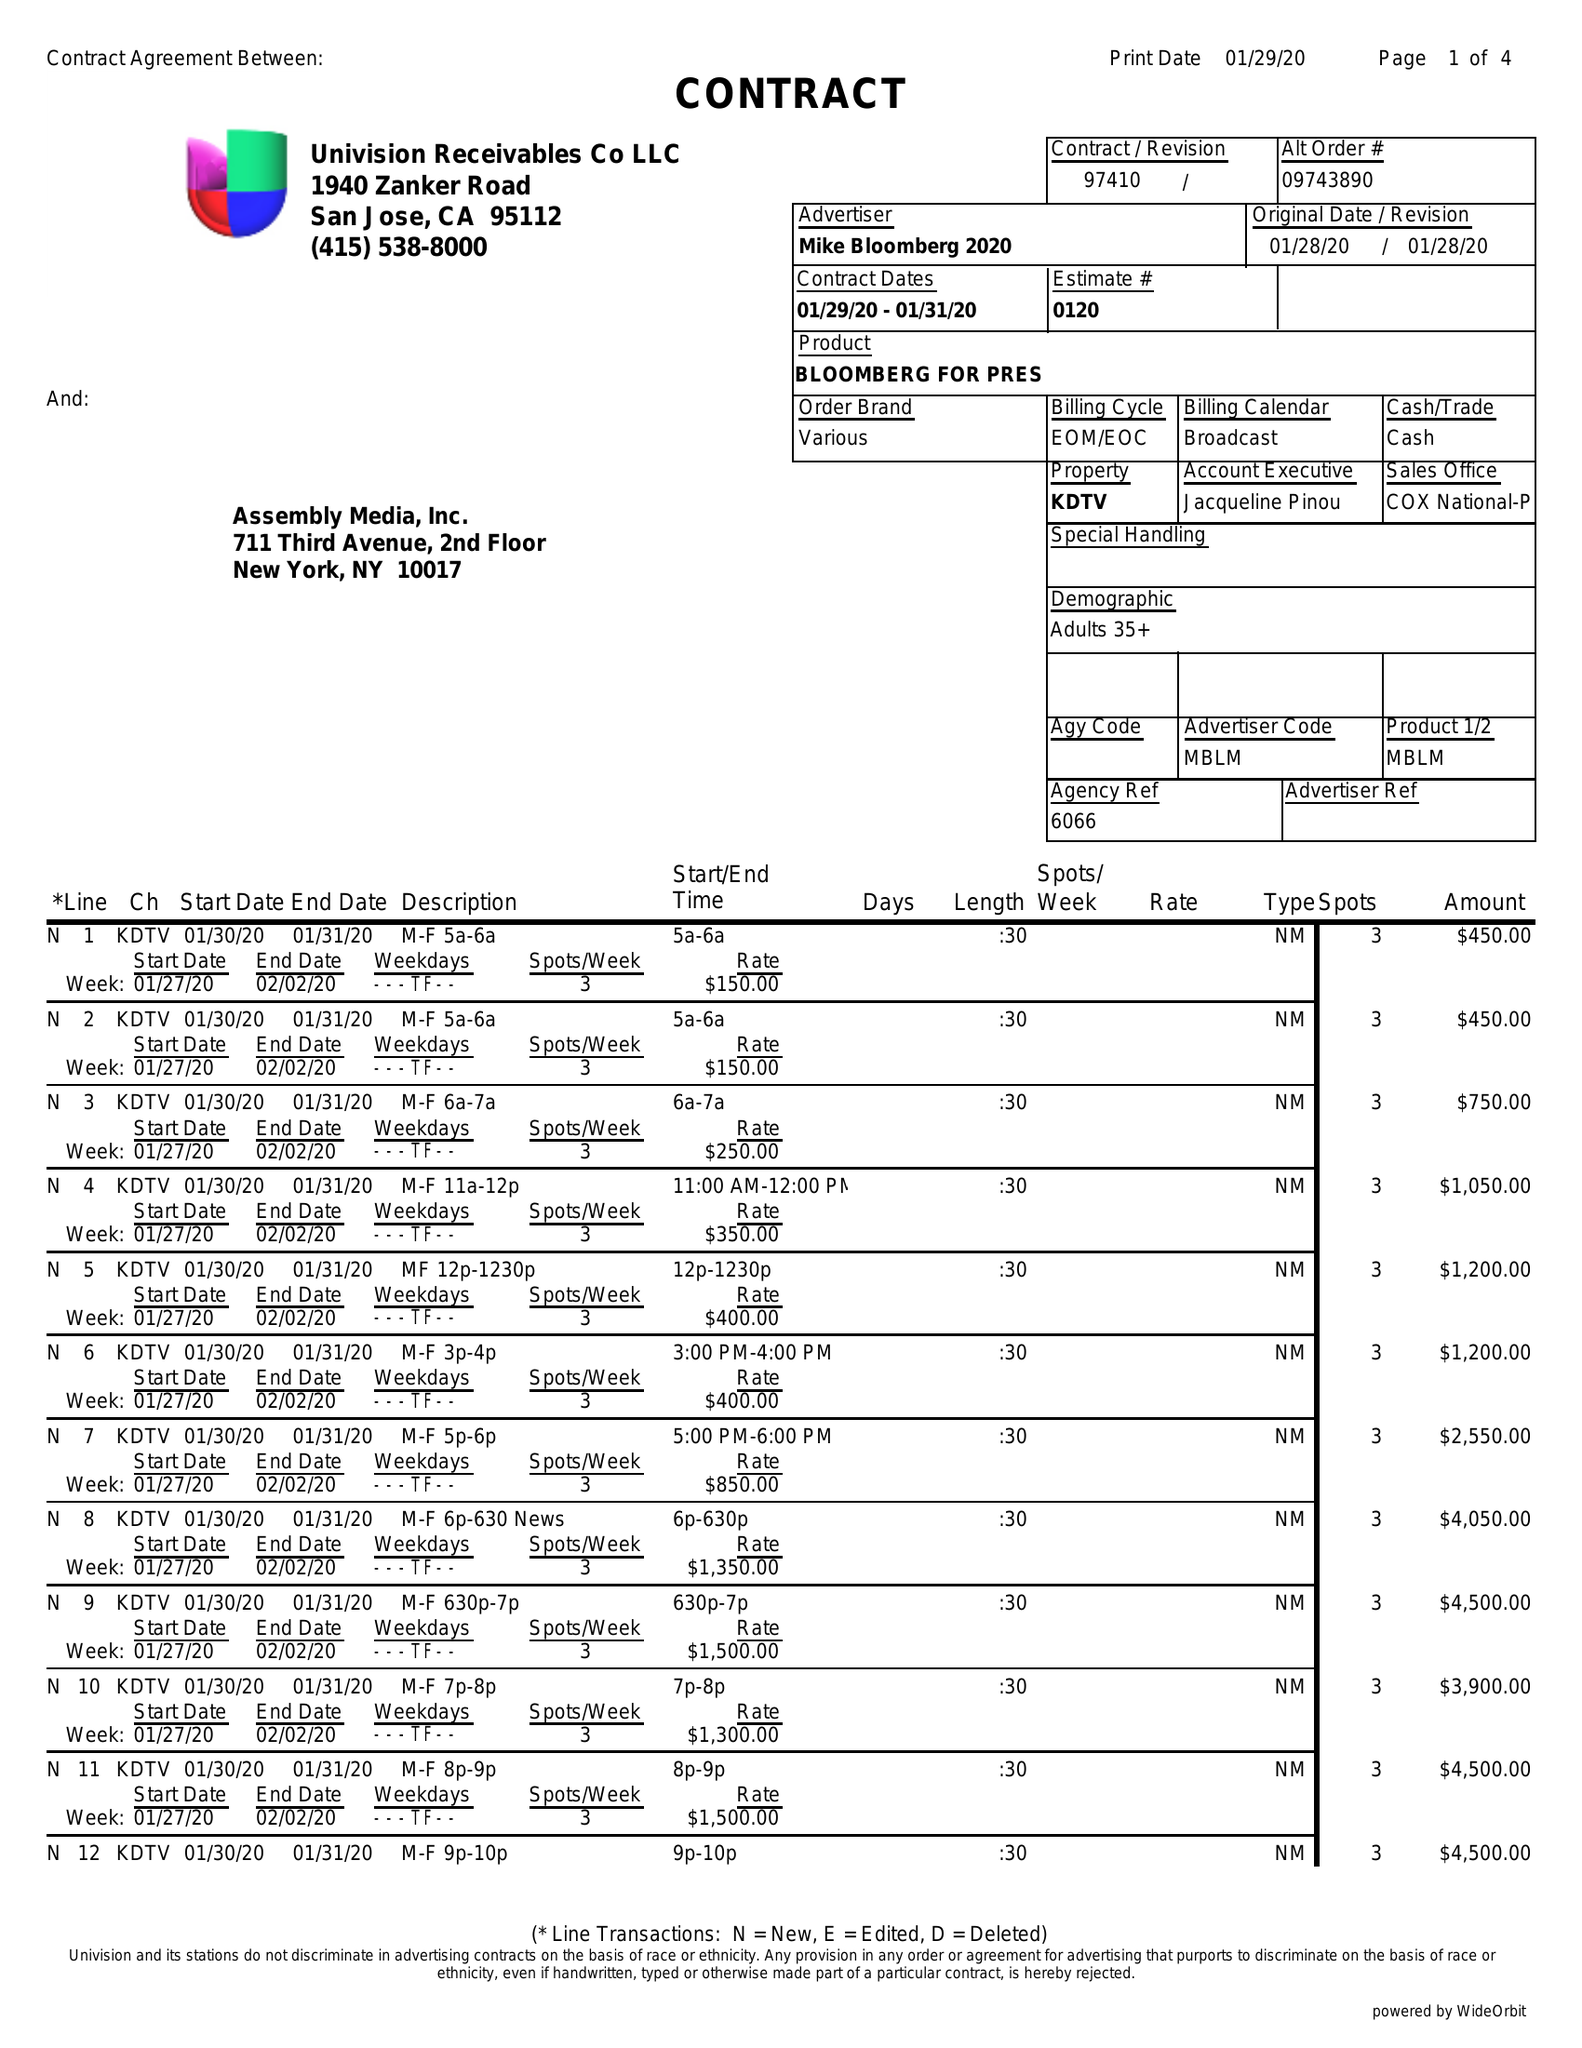What is the value for the flight_from?
Answer the question using a single word or phrase. 01/29/20 